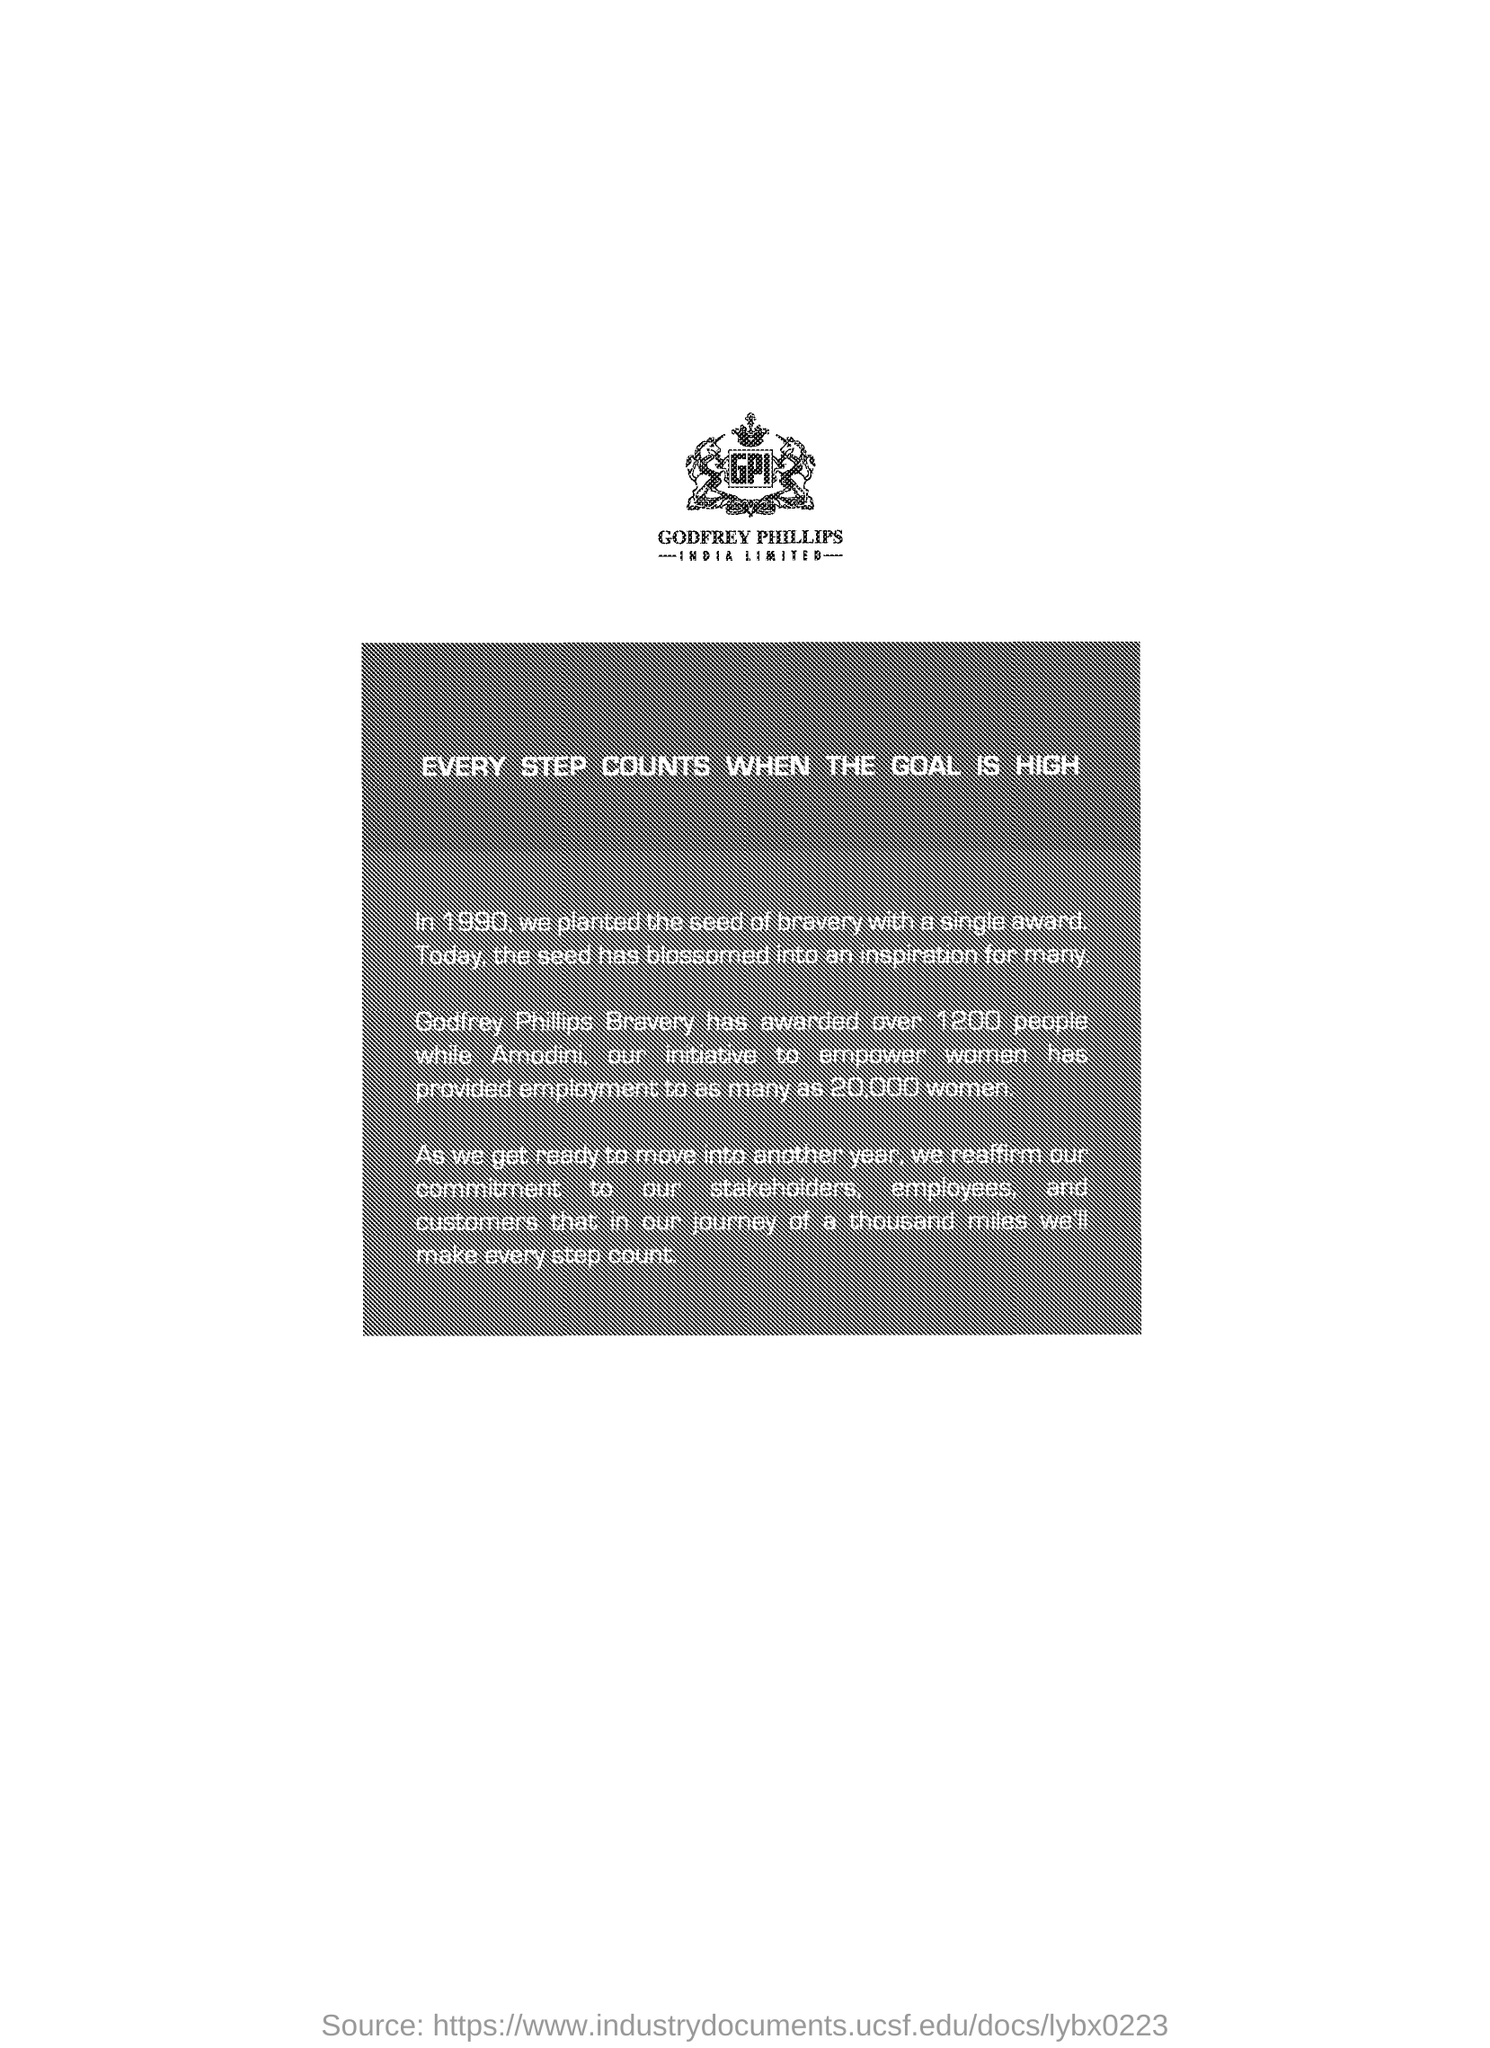In which year they planted the seed of bravery with a single award ?
Your response must be concise. 1990. Godfrey Phillips bravery has awarded over how many people ?
Offer a terse response. 1200. Amodini , our initiative to empower women has provided employment to as many as how many women ?
Give a very brief answer. 20,000. 